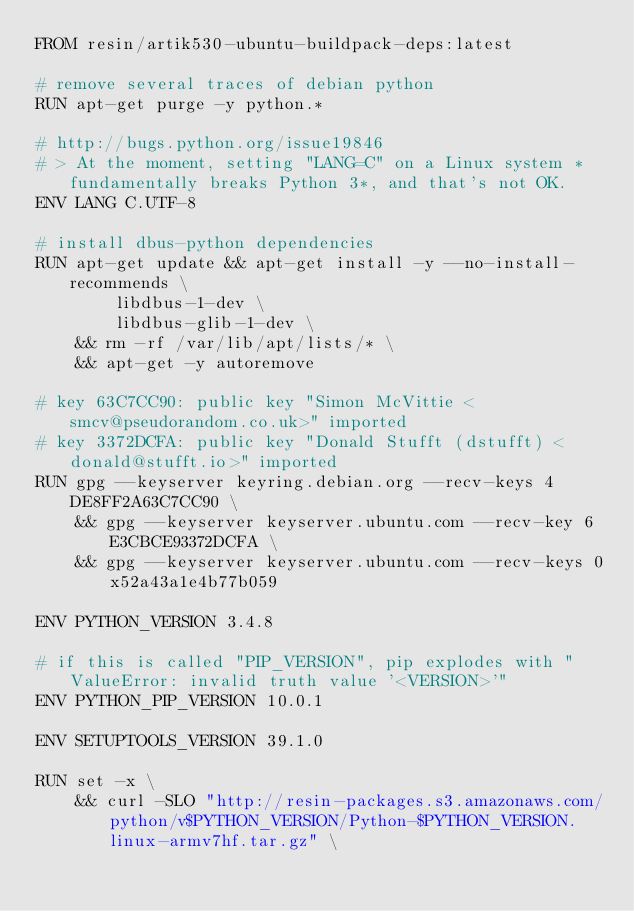<code> <loc_0><loc_0><loc_500><loc_500><_Dockerfile_>FROM resin/artik530-ubuntu-buildpack-deps:latest

# remove several traces of debian python
RUN apt-get purge -y python.*

# http://bugs.python.org/issue19846
# > At the moment, setting "LANG=C" on a Linux system *fundamentally breaks Python 3*, and that's not OK.
ENV LANG C.UTF-8

# install dbus-python dependencies 
RUN apt-get update && apt-get install -y --no-install-recommends \
		libdbus-1-dev \
		libdbus-glib-1-dev \
	&& rm -rf /var/lib/apt/lists/* \
	&& apt-get -y autoremove

# key 63C7CC90: public key "Simon McVittie <smcv@pseudorandom.co.uk>" imported
# key 3372DCFA: public key "Donald Stufft (dstufft) <donald@stufft.io>" imported
RUN gpg --keyserver keyring.debian.org --recv-keys 4DE8FF2A63C7CC90 \
	&& gpg --keyserver keyserver.ubuntu.com --recv-key 6E3CBCE93372DCFA \
	&& gpg --keyserver keyserver.ubuntu.com --recv-keys 0x52a43a1e4b77b059

ENV PYTHON_VERSION 3.4.8

# if this is called "PIP_VERSION", pip explodes with "ValueError: invalid truth value '<VERSION>'"
ENV PYTHON_PIP_VERSION 10.0.1

ENV SETUPTOOLS_VERSION 39.1.0

RUN set -x \
	&& curl -SLO "http://resin-packages.s3.amazonaws.com/python/v$PYTHON_VERSION/Python-$PYTHON_VERSION.linux-armv7hf.tar.gz" \</code> 